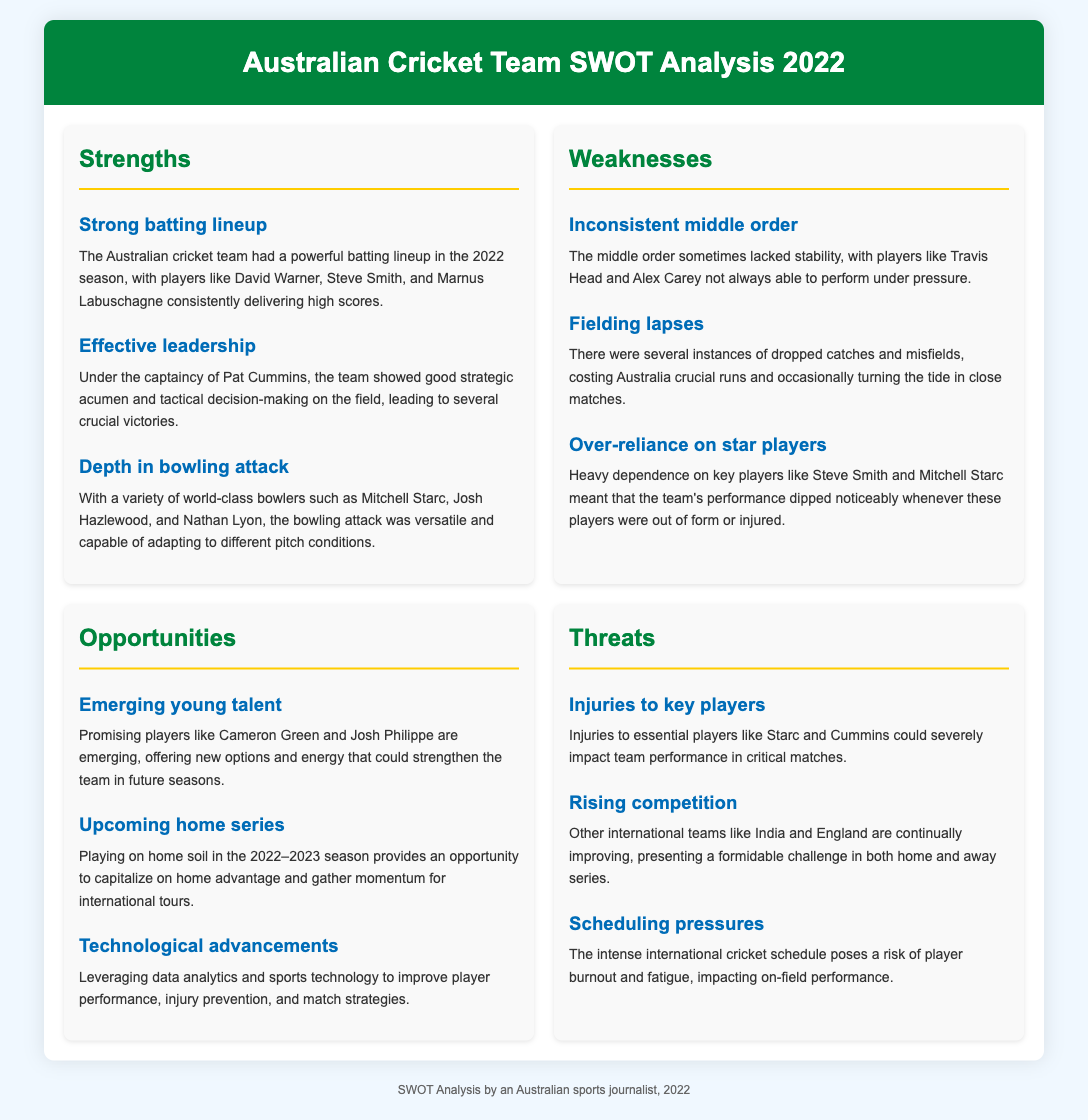what are the strengths of the Australian cricket team in 2022? The strengths listed in the document include a strong batting lineup, effective leadership, and depth in the bowling attack.
Answer: strong batting lineup, effective leadership, depth in bowling attack who are considered key players in the Australian cricket team's batting lineup? The key players mentioned for the batting lineup are David Warner, Steve Smith, and Marnus Labuschagne.
Answer: David Warner, Steve Smith, Marnus Labuschagne what was a noted weakness regarding the team's middle order? The middle order was noted for being inconsistent, particularly with players like Travis Head and Alex Carey.
Answer: inconsistent what opportunity is highlighted regarding young talent? The emerging young talent mentioned includes players like Cameron Green and Josh Philippe, which can strengthen the team.
Answer: Cameron Green, Josh Philippe what is a significant threat to the team's performance? Injuries to key players such as Starc and Cummins present a significant threat to the team's performance.
Answer: Injuries to key players what leadership role does Pat Cummins hold in the team? Pat Cummins is the captain of the Australian cricket team, as noted in the document.
Answer: captain how does the document classify the next home series? The upcoming home series is classified as an opportunity for the team to capitalize on home advantage.
Answer: opportunity what technological aspect is proposed to improve team performance? The document suggests leveraging data analytics and sports technology for improving performance and strategies.
Answer: data analytics and sports technology 